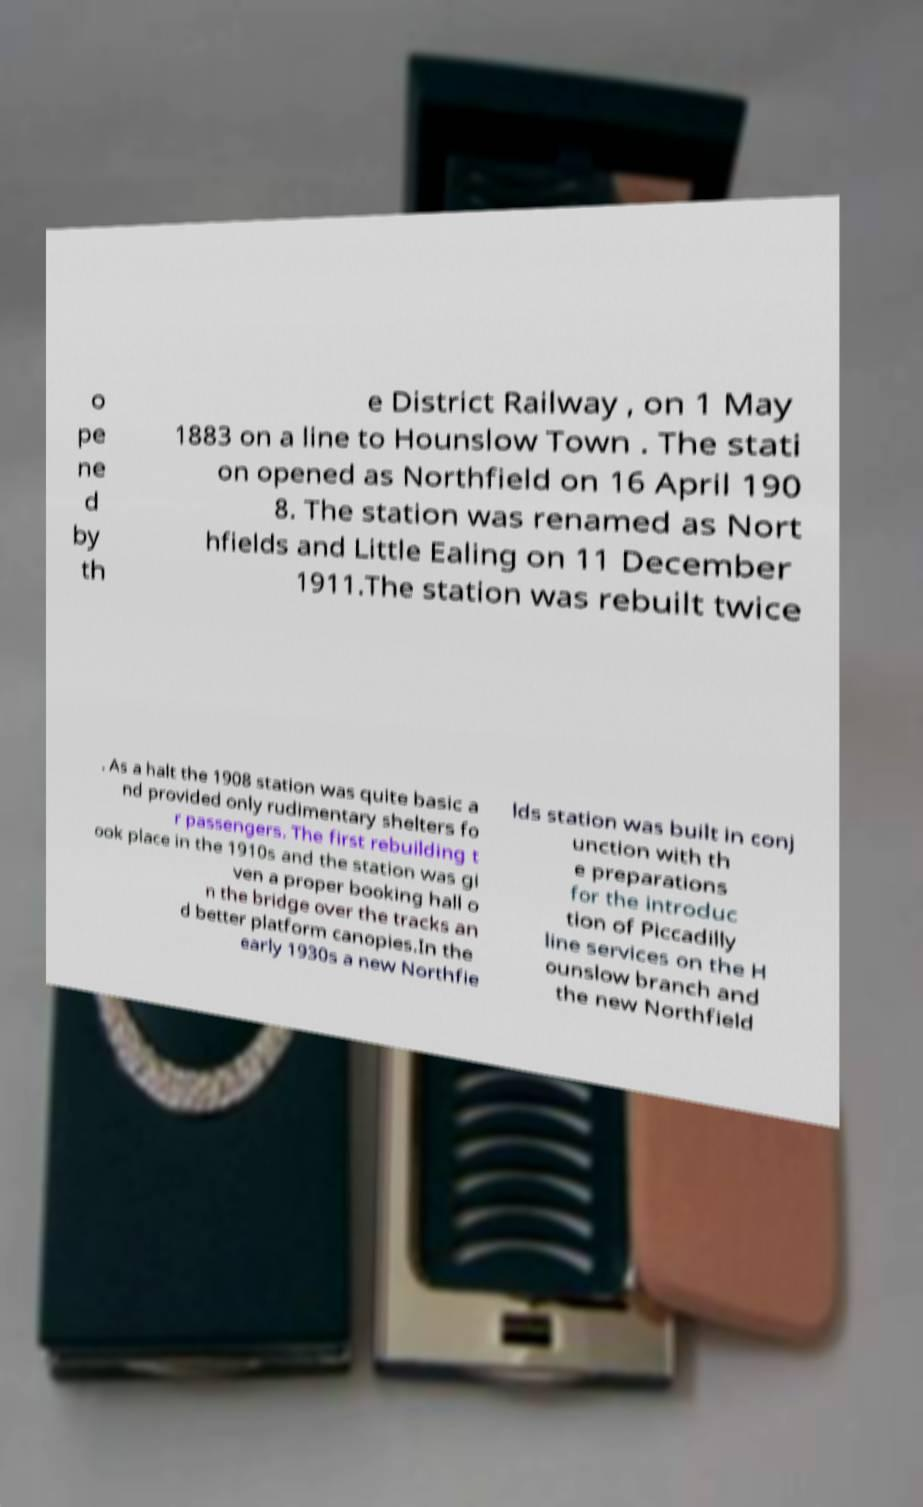Please read and relay the text visible in this image. What does it say? o pe ne d by th e District Railway , on 1 May 1883 on a line to Hounslow Town . The stati on opened as Northfield on 16 April 190 8. The station was renamed as Nort hfields and Little Ealing on 11 December 1911.The station was rebuilt twice . As a halt the 1908 station was quite basic a nd provided only rudimentary shelters fo r passengers. The first rebuilding t ook place in the 1910s and the station was gi ven a proper booking hall o n the bridge over the tracks an d better platform canopies.In the early 1930s a new Northfie lds station was built in conj unction with th e preparations for the introduc tion of Piccadilly line services on the H ounslow branch and the new Northfield 